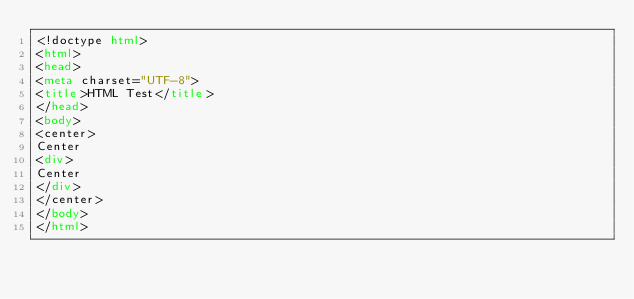Convert code to text. <code><loc_0><loc_0><loc_500><loc_500><_HTML_><!doctype html>
<html>
<head>
<meta charset="UTF-8">
<title>HTML Test</title>
</head>
<body>
<center>
Center
<div>
Center
</div>
</center>
</body>
</html>
</code> 